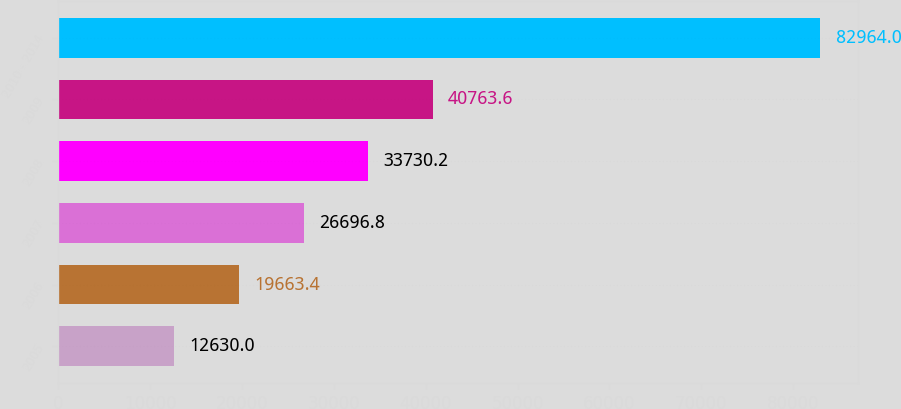Convert chart to OTSL. <chart><loc_0><loc_0><loc_500><loc_500><bar_chart><fcel>2005<fcel>2006<fcel>2007<fcel>2008<fcel>2009<fcel>2010 - 2014<nl><fcel>12630<fcel>19663.4<fcel>26696.8<fcel>33730.2<fcel>40763.6<fcel>82964<nl></chart> 